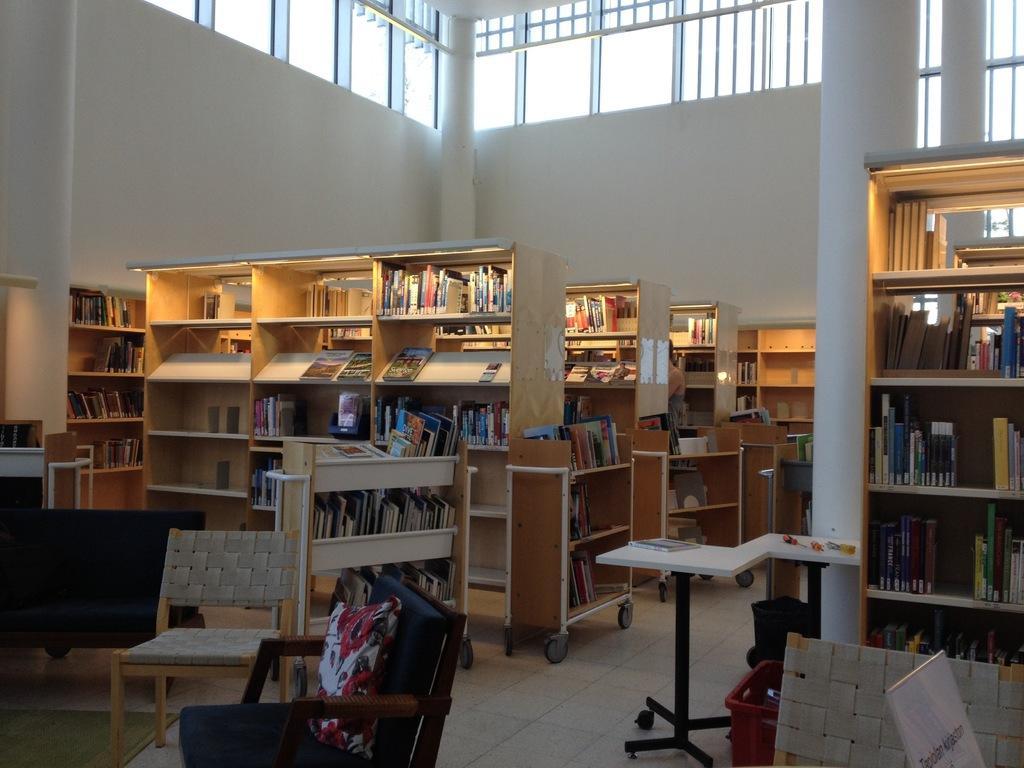Describe this image in one or two sentences. There is a chair , two chairs one looks like a sofa and there are bookshelves. There are so many books in that shelves. There are four pillars here. There is a table, a book is placed on the table. There is a person standing in the middle of the room near the bookshelf. there are windows here. 